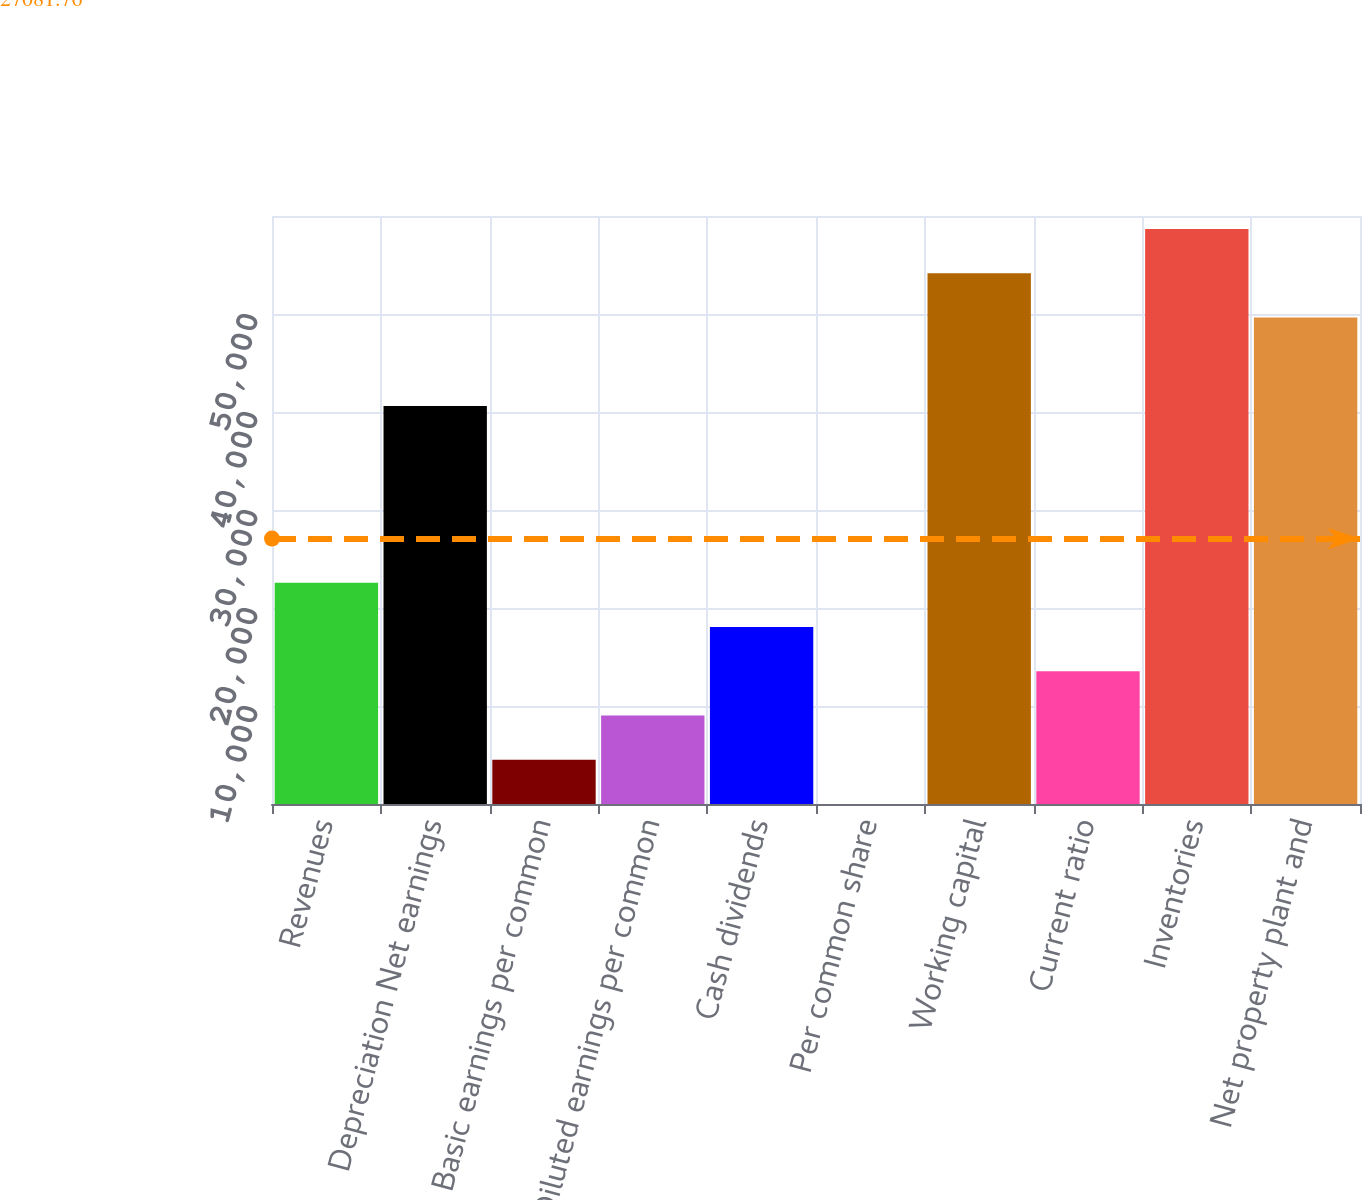Convert chart. <chart><loc_0><loc_0><loc_500><loc_500><bar_chart><fcel>Revenues<fcel>Depreciation Net earnings<fcel>Basic earnings per common<fcel>Diluted earnings per common<fcel>Cash dividends<fcel>Per common share<fcel>Working capital<fcel>Current ratio<fcel>Inventories<fcel>Net property plant and<nl><fcel>22568.2<fcel>40622.5<fcel>4513.92<fcel>9027.49<fcel>18054.6<fcel>0.35<fcel>54163.2<fcel>13541.1<fcel>58676.7<fcel>49649.6<nl></chart> 